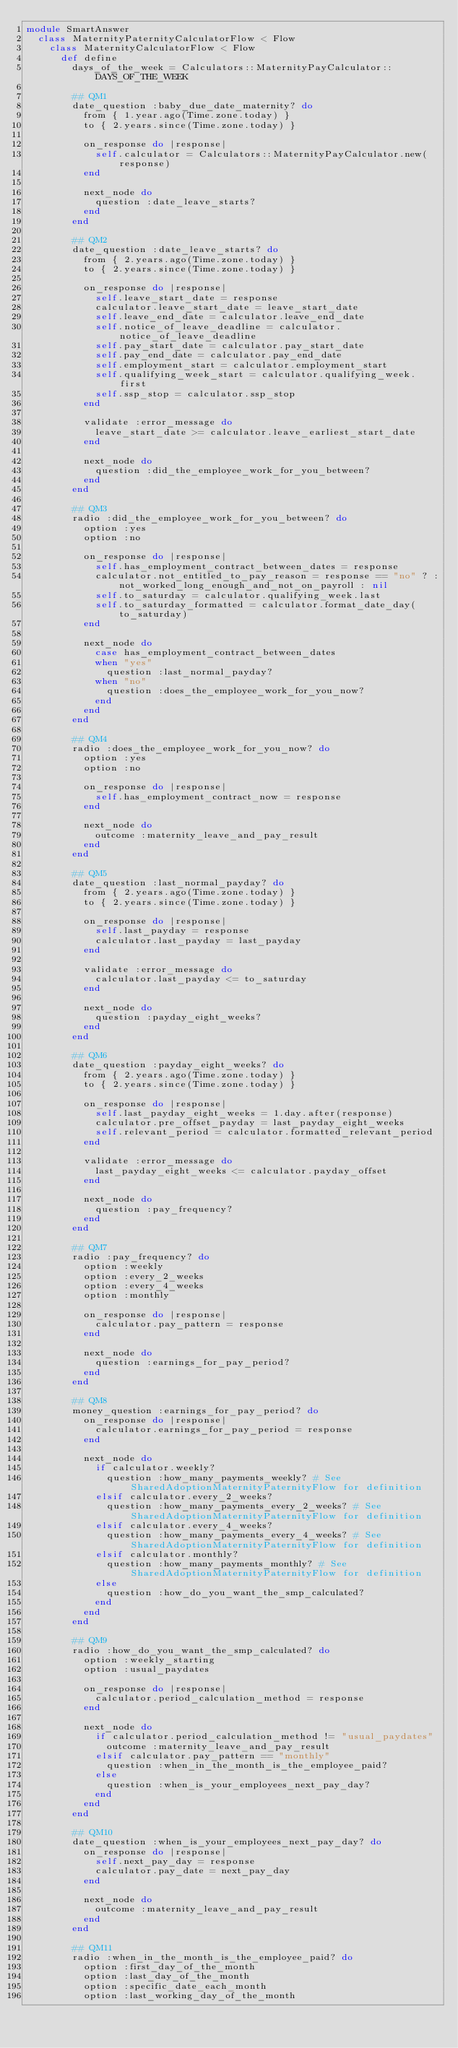Convert code to text. <code><loc_0><loc_0><loc_500><loc_500><_Ruby_>module SmartAnswer
  class MaternityPaternityCalculatorFlow < Flow
    class MaternityCalculatorFlow < Flow
      def define
        days_of_the_week = Calculators::MaternityPayCalculator::DAYS_OF_THE_WEEK

        ## QM1
        date_question :baby_due_date_maternity? do
          from { 1.year.ago(Time.zone.today) }
          to { 2.years.since(Time.zone.today) }

          on_response do |response|
            self.calculator = Calculators::MaternityPayCalculator.new(response)
          end

          next_node do
            question :date_leave_starts?
          end
        end

        ## QM2
        date_question :date_leave_starts? do
          from { 2.years.ago(Time.zone.today) }
          to { 2.years.since(Time.zone.today) }

          on_response do |response|
            self.leave_start_date = response
            calculator.leave_start_date = leave_start_date
            self.leave_end_date = calculator.leave_end_date
            self.notice_of_leave_deadline = calculator.notice_of_leave_deadline
            self.pay_start_date = calculator.pay_start_date
            self.pay_end_date = calculator.pay_end_date
            self.employment_start = calculator.employment_start
            self.qualifying_week_start = calculator.qualifying_week.first
            self.ssp_stop = calculator.ssp_stop
          end

          validate :error_message do
            leave_start_date >= calculator.leave_earliest_start_date
          end

          next_node do
            question :did_the_employee_work_for_you_between?
          end
        end

        ## QM3
        radio :did_the_employee_work_for_you_between? do
          option :yes
          option :no

          on_response do |response|
            self.has_employment_contract_between_dates = response
            calculator.not_entitled_to_pay_reason = response == "no" ? :not_worked_long_enough_and_not_on_payroll : nil
            self.to_saturday = calculator.qualifying_week.last
            self.to_saturday_formatted = calculator.format_date_day(to_saturday)
          end

          next_node do
            case has_employment_contract_between_dates
            when "yes"
              question :last_normal_payday?
            when "no"
              question :does_the_employee_work_for_you_now?
            end
          end
        end

        ## QM4
        radio :does_the_employee_work_for_you_now? do
          option :yes
          option :no

          on_response do |response|
            self.has_employment_contract_now = response
          end

          next_node do
            outcome :maternity_leave_and_pay_result
          end
        end

        ## QM5
        date_question :last_normal_payday? do
          from { 2.years.ago(Time.zone.today) }
          to { 2.years.since(Time.zone.today) }

          on_response do |response|
            self.last_payday = response
            calculator.last_payday = last_payday
          end

          validate :error_message do
            calculator.last_payday <= to_saturday
          end

          next_node do
            question :payday_eight_weeks?
          end
        end

        ## QM6
        date_question :payday_eight_weeks? do
          from { 2.years.ago(Time.zone.today) }
          to { 2.years.since(Time.zone.today) }

          on_response do |response|
            self.last_payday_eight_weeks = 1.day.after(response)
            calculator.pre_offset_payday = last_payday_eight_weeks
            self.relevant_period = calculator.formatted_relevant_period
          end

          validate :error_message do
            last_payday_eight_weeks <= calculator.payday_offset
          end

          next_node do
            question :pay_frequency?
          end
        end

        ## QM7
        radio :pay_frequency? do
          option :weekly
          option :every_2_weeks
          option :every_4_weeks
          option :monthly

          on_response do |response|
            calculator.pay_pattern = response
          end

          next_node do
            question :earnings_for_pay_period?
          end
        end

        ## QM8
        money_question :earnings_for_pay_period? do
          on_response do |response|
            calculator.earnings_for_pay_period = response
          end

          next_node do
            if calculator.weekly?
              question :how_many_payments_weekly? # See SharedAdoptionMaternityPaternityFlow for definition
            elsif calculator.every_2_weeks?
              question :how_many_payments_every_2_weeks? # See SharedAdoptionMaternityPaternityFlow for definition
            elsif calculator.every_4_weeks?
              question :how_many_payments_every_4_weeks? # See SharedAdoptionMaternityPaternityFlow for definition
            elsif calculator.monthly?
              question :how_many_payments_monthly? # See SharedAdoptionMaternityPaternityFlow for definition
            else
              question :how_do_you_want_the_smp_calculated?
            end
          end
        end

        ## QM9
        radio :how_do_you_want_the_smp_calculated? do
          option :weekly_starting
          option :usual_paydates

          on_response do |response|
            calculator.period_calculation_method = response
          end

          next_node do
            if calculator.period_calculation_method != "usual_paydates"
              outcome :maternity_leave_and_pay_result
            elsif calculator.pay_pattern == "monthly"
              question :when_in_the_month_is_the_employee_paid?
            else
              question :when_is_your_employees_next_pay_day?
            end
          end
        end

        ## QM10
        date_question :when_is_your_employees_next_pay_day? do
          on_response do |response|
            self.next_pay_day = response
            calculator.pay_date = next_pay_day
          end

          next_node do
            outcome :maternity_leave_and_pay_result
          end
        end

        ## QM11
        radio :when_in_the_month_is_the_employee_paid? do
          option :first_day_of_the_month
          option :last_day_of_the_month
          option :specific_date_each_month
          option :last_working_day_of_the_month</code> 